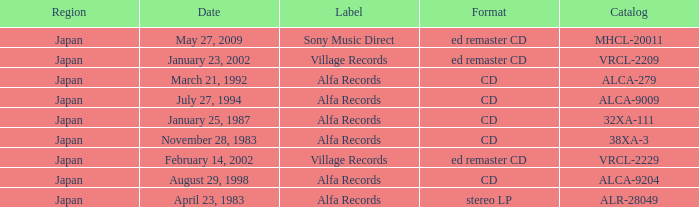Which date is in CD format? November 28, 1983, January 25, 1987, March 21, 1992, July 27, 1994, August 29, 1998. 